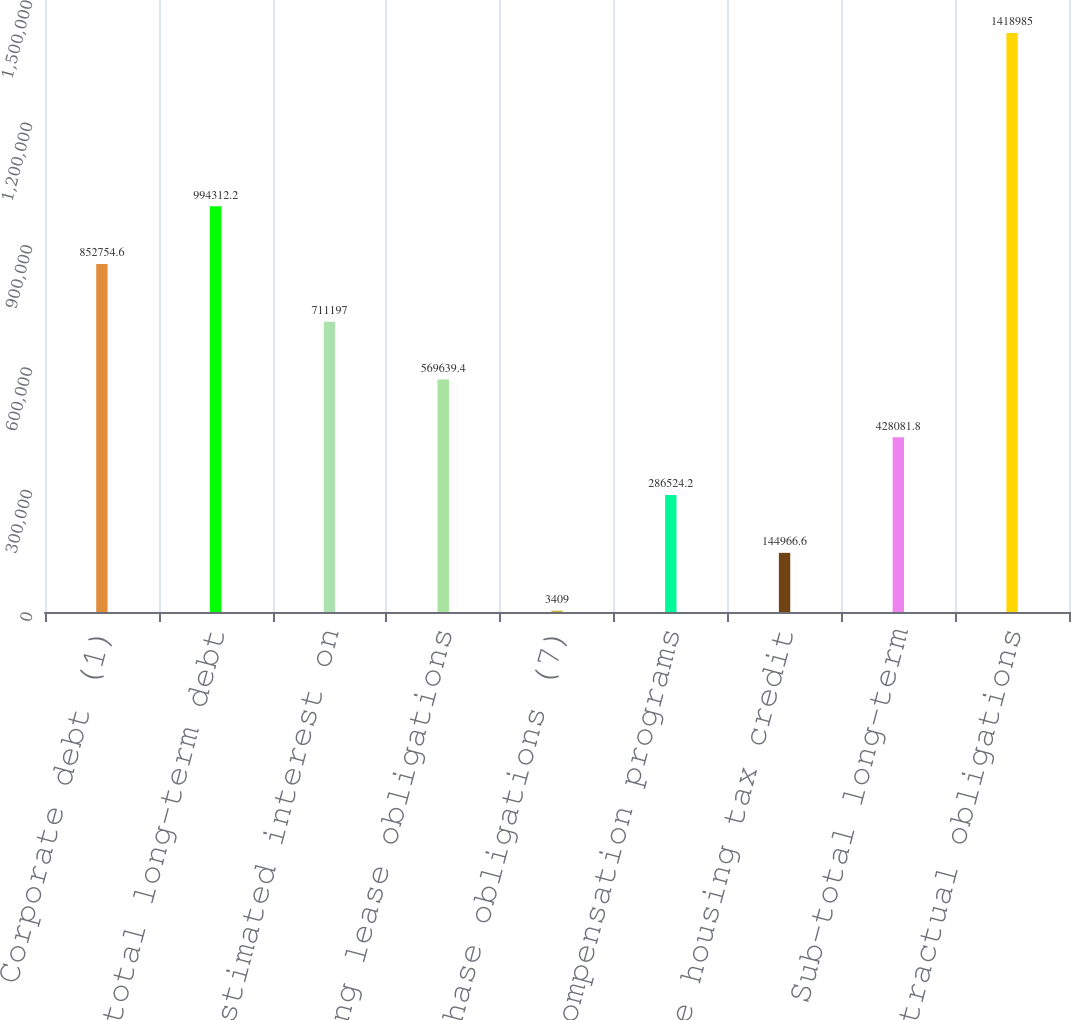Convert chart to OTSL. <chart><loc_0><loc_0><loc_500><loc_500><bar_chart><fcel>Corporate debt (1)<fcel>Sub-total long-term debt<fcel>Estimated interest on<fcel>Operating lease obligations<fcel>Purchase obligations (7)<fcel>Deferred compensation programs<fcel>Low income housing tax credit<fcel>Sub-total long-term<fcel>Total contractual obligations<nl><fcel>852755<fcel>994312<fcel>711197<fcel>569639<fcel>3409<fcel>286524<fcel>144967<fcel>428082<fcel>1.41898e+06<nl></chart> 